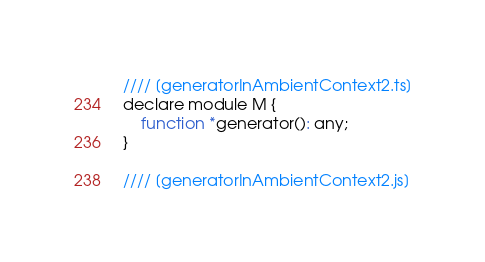<code> <loc_0><loc_0><loc_500><loc_500><_JavaScript_>//// [generatorInAmbientContext2.ts]
declare module M {
    function *generator(): any;
}

//// [generatorInAmbientContext2.js]
</code> 